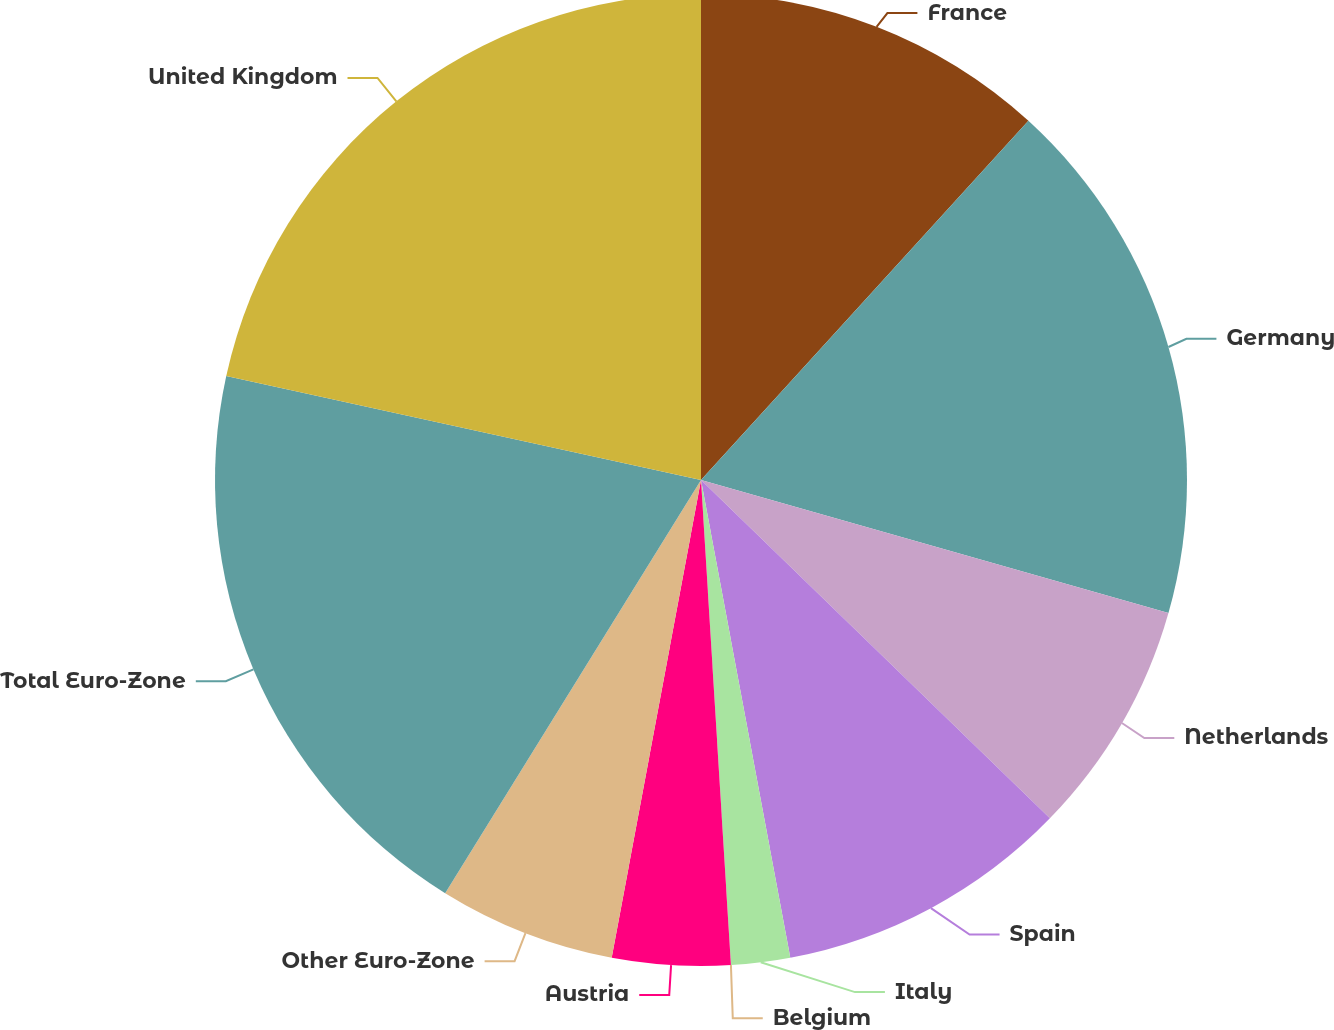Convert chart to OTSL. <chart><loc_0><loc_0><loc_500><loc_500><pie_chart><fcel>France<fcel>Germany<fcel>Netherlands<fcel>Spain<fcel>Italy<fcel>Belgium<fcel>Austria<fcel>Other Euro-Zone<fcel>Total Euro-Zone<fcel>United Kingdom<nl><fcel>11.76%<fcel>17.64%<fcel>7.84%<fcel>9.8%<fcel>1.96%<fcel>0.0%<fcel>3.92%<fcel>5.88%<fcel>19.6%<fcel>21.56%<nl></chart> 